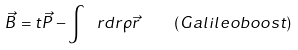Convert formula to latex. <formula><loc_0><loc_0><loc_500><loc_500>\vec { B } = t \vec { P } - \int \ r d r \rho \vec { r } \quad ( G a l i l e o b o o s t )</formula> 